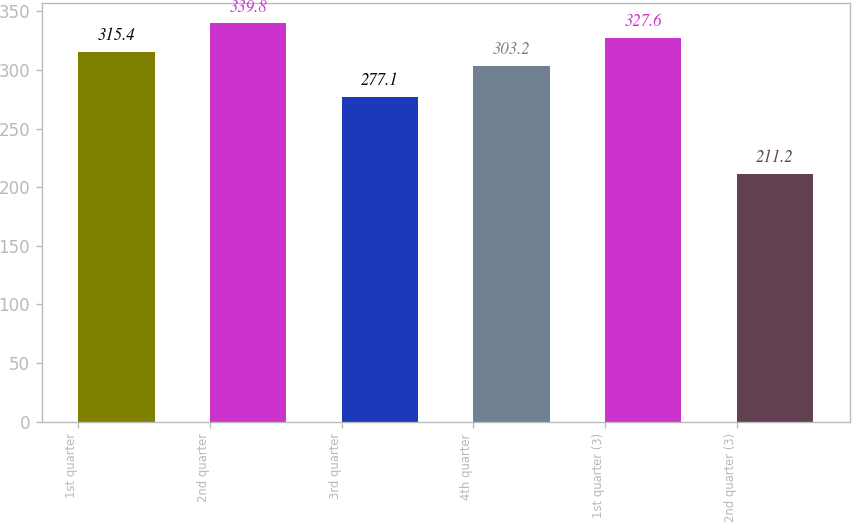Convert chart to OTSL. <chart><loc_0><loc_0><loc_500><loc_500><bar_chart><fcel>1st quarter<fcel>2nd quarter<fcel>3rd quarter<fcel>4th quarter<fcel>1st quarter (3)<fcel>2nd quarter (3)<nl><fcel>315.4<fcel>339.8<fcel>277.1<fcel>303.2<fcel>327.6<fcel>211.2<nl></chart> 